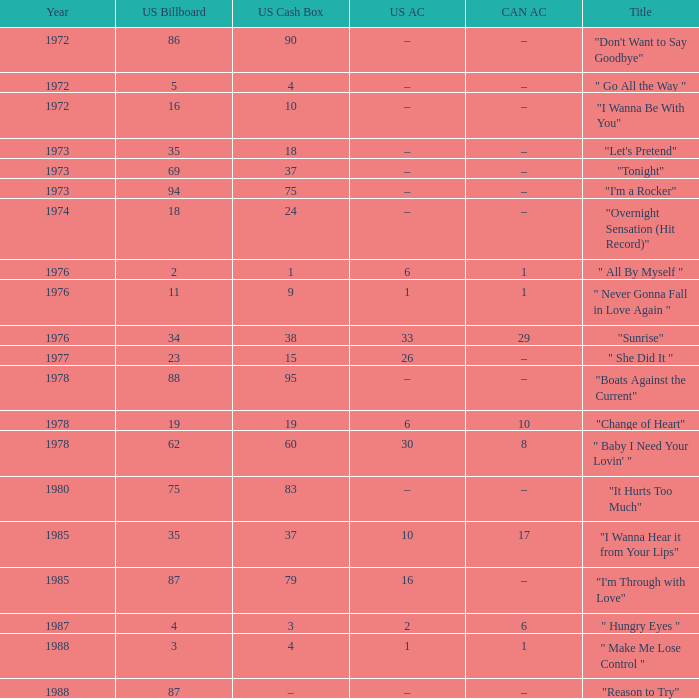What is the us money container prior to 1978 with a us billboard ranking of 35? 18.0. 